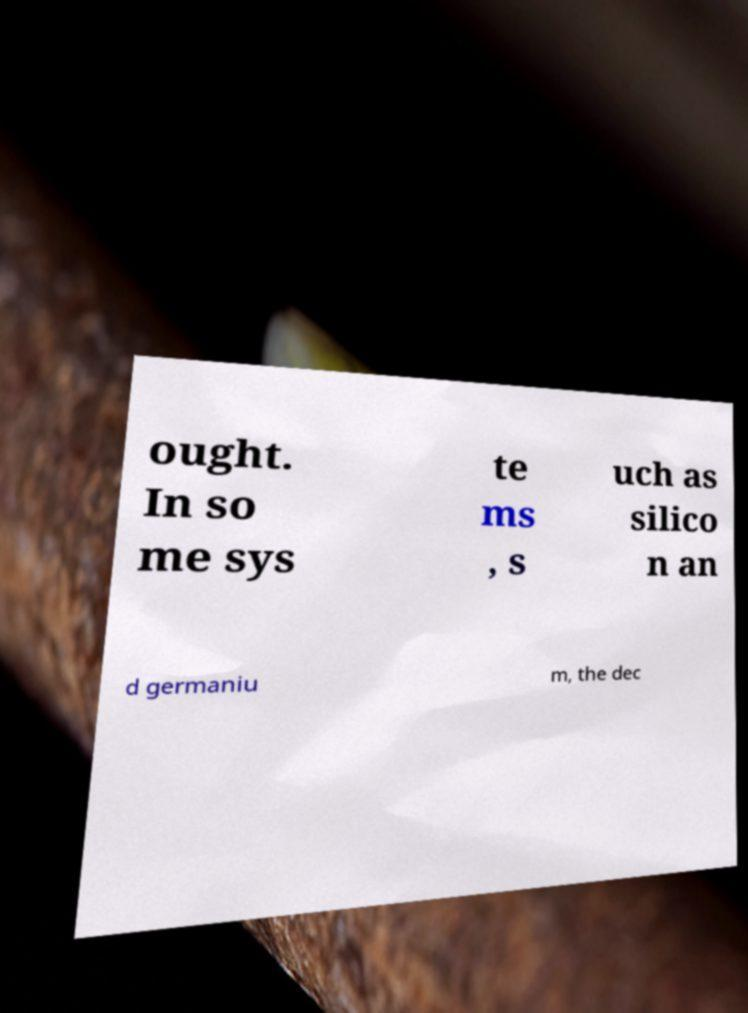For documentation purposes, I need the text within this image transcribed. Could you provide that? ought. In so me sys te ms , s uch as silico n an d germaniu m, the dec 